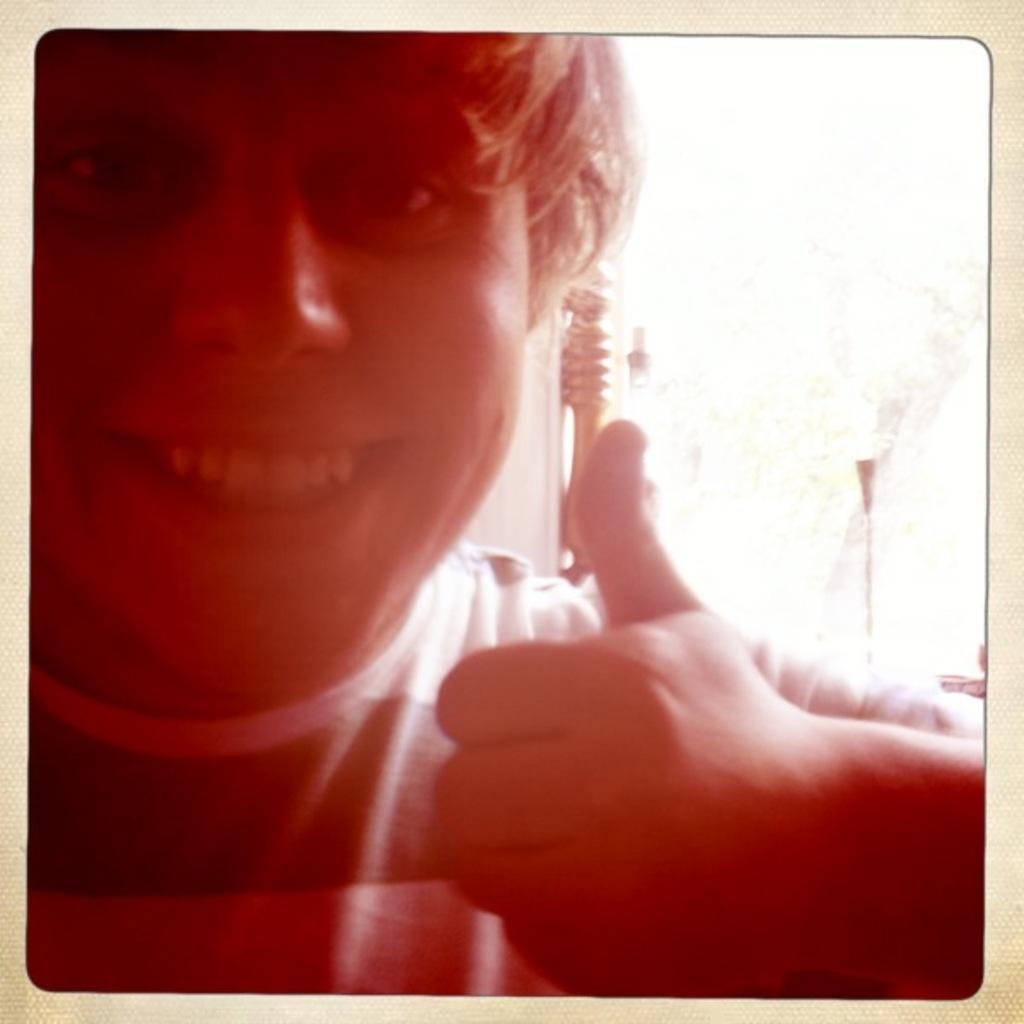Who is present in the image? There is a person in the image. What is the person wearing? The person is wearing a t-shirt. What is the person doing with their hand? The person is showing their thumb finger. What can be seen in the background of the image? There is a group of poles in the background of the image. What type of boats can be seen in the image? There are no boats present in the image; it features a person wearing a t-shirt and showing their thumb finger, with a group of poles in the background. 